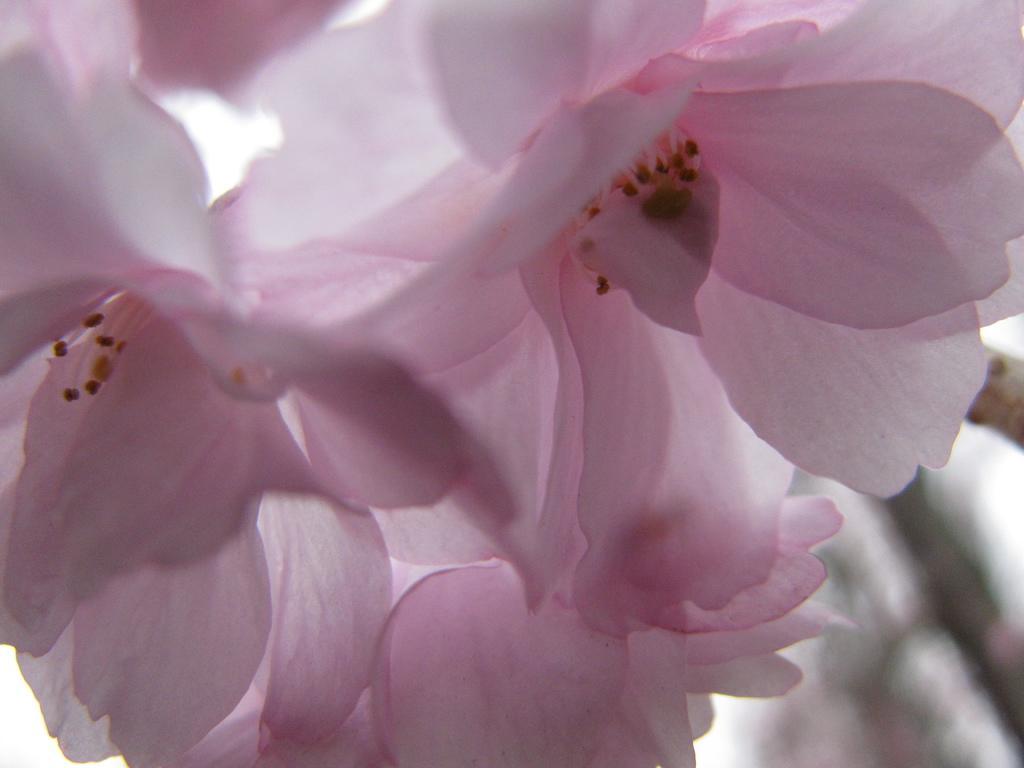How would you summarize this image in a sentence or two? In this image in the foreground there are many pink color flowers. 